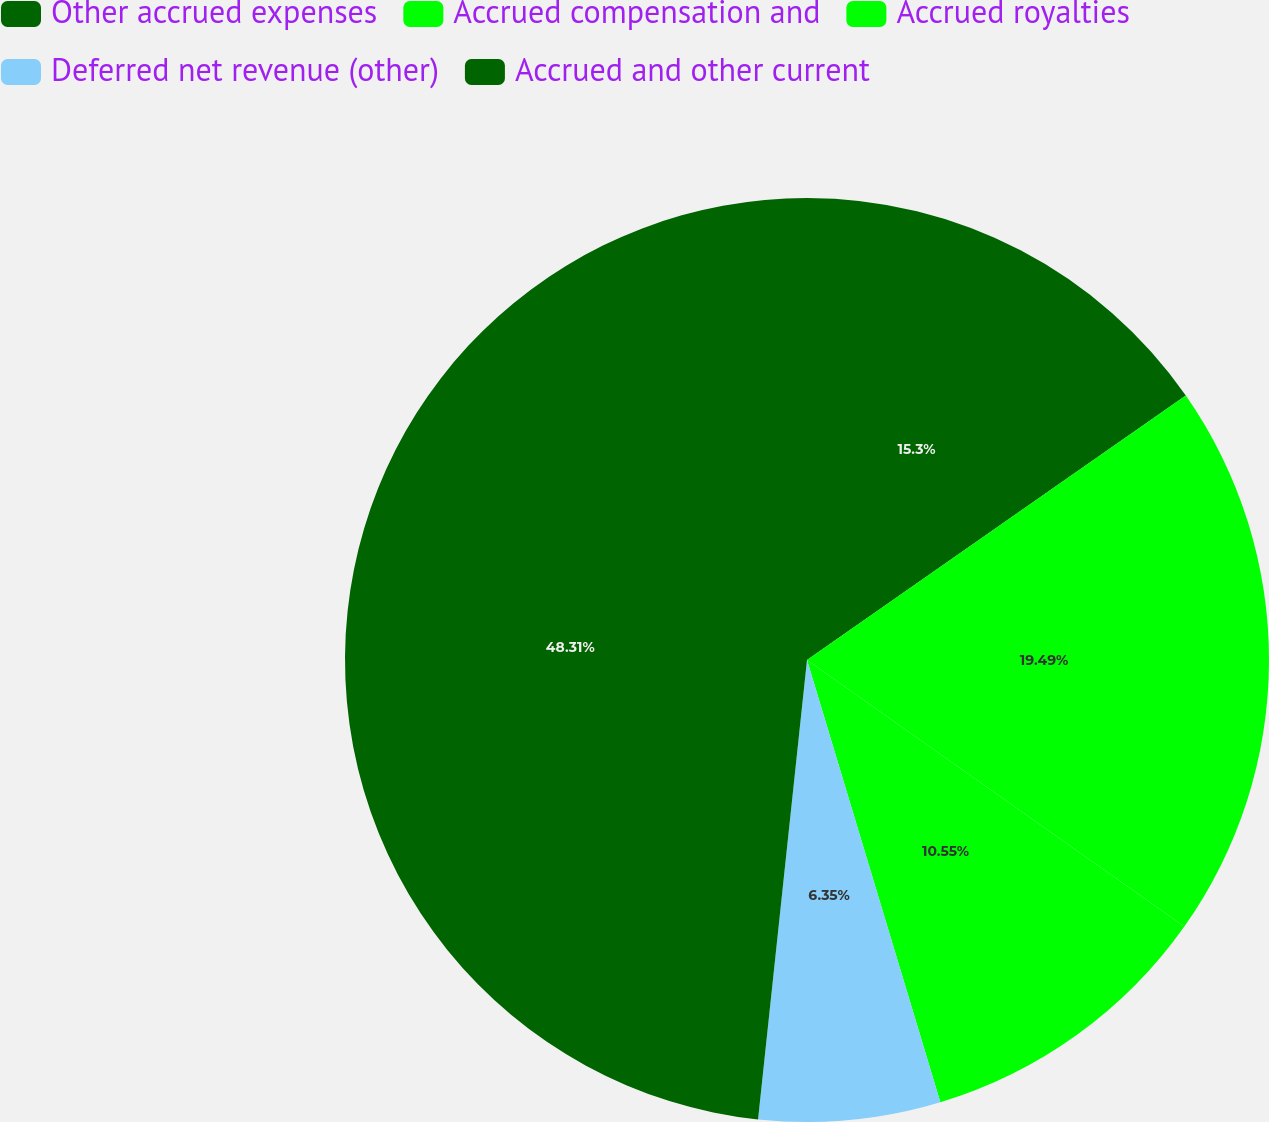Convert chart to OTSL. <chart><loc_0><loc_0><loc_500><loc_500><pie_chart><fcel>Other accrued expenses<fcel>Accrued compensation and<fcel>Accrued royalties<fcel>Deferred net revenue (other)<fcel>Accrued and other current<nl><fcel>15.3%<fcel>19.49%<fcel>10.55%<fcel>6.35%<fcel>48.31%<nl></chart> 